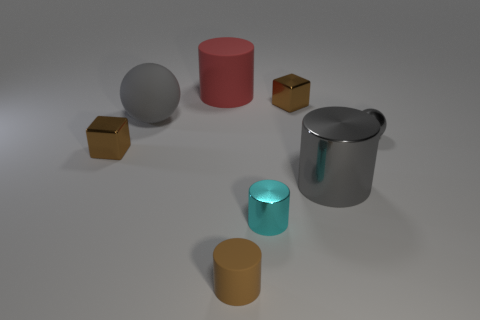Do the large sphere and the big cylinder in front of the small gray metallic sphere have the same color?
Offer a terse response. Yes. What number of other things are there of the same material as the small gray thing
Your response must be concise. 4. Is the number of big gray matte spheres greater than the number of large cylinders?
Keep it short and to the point. No. Do the tiny metal thing behind the gray metallic ball and the tiny matte object have the same color?
Provide a succinct answer. Yes. The big metallic thing is what color?
Provide a short and direct response. Gray. There is a gray thing on the left side of the gray cylinder; is there a big red rubber thing to the right of it?
Give a very brief answer. Yes. What shape is the small brown shiny thing behind the small shiny object to the left of the tiny brown matte cylinder?
Ensure brevity in your answer.  Cube. Is the number of tiny gray shiny balls less than the number of cylinders?
Offer a very short reply. Yes. Do the large gray ball and the red thing have the same material?
Make the answer very short. Yes. What is the color of the big object that is right of the large gray ball and in front of the red rubber thing?
Make the answer very short. Gray. 